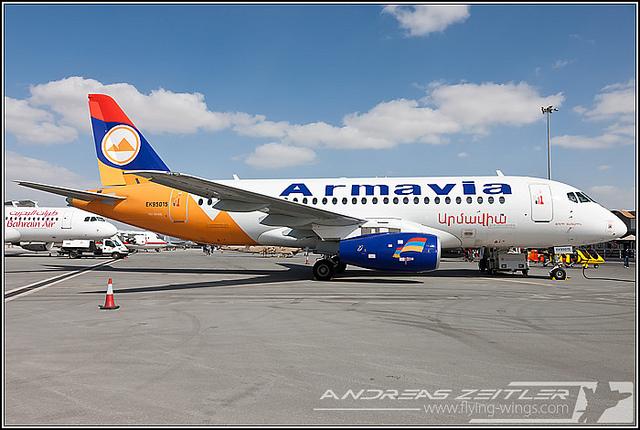Is that airline expensive?
Answer briefly. No. What is the weather like?
Quick response, please. Sunny. Where can more information about this plane be found?
Write a very short answer. Website. Where are the planes?
Write a very short answer. Airport. What airline does this represent?
Give a very brief answer. Armavia. 